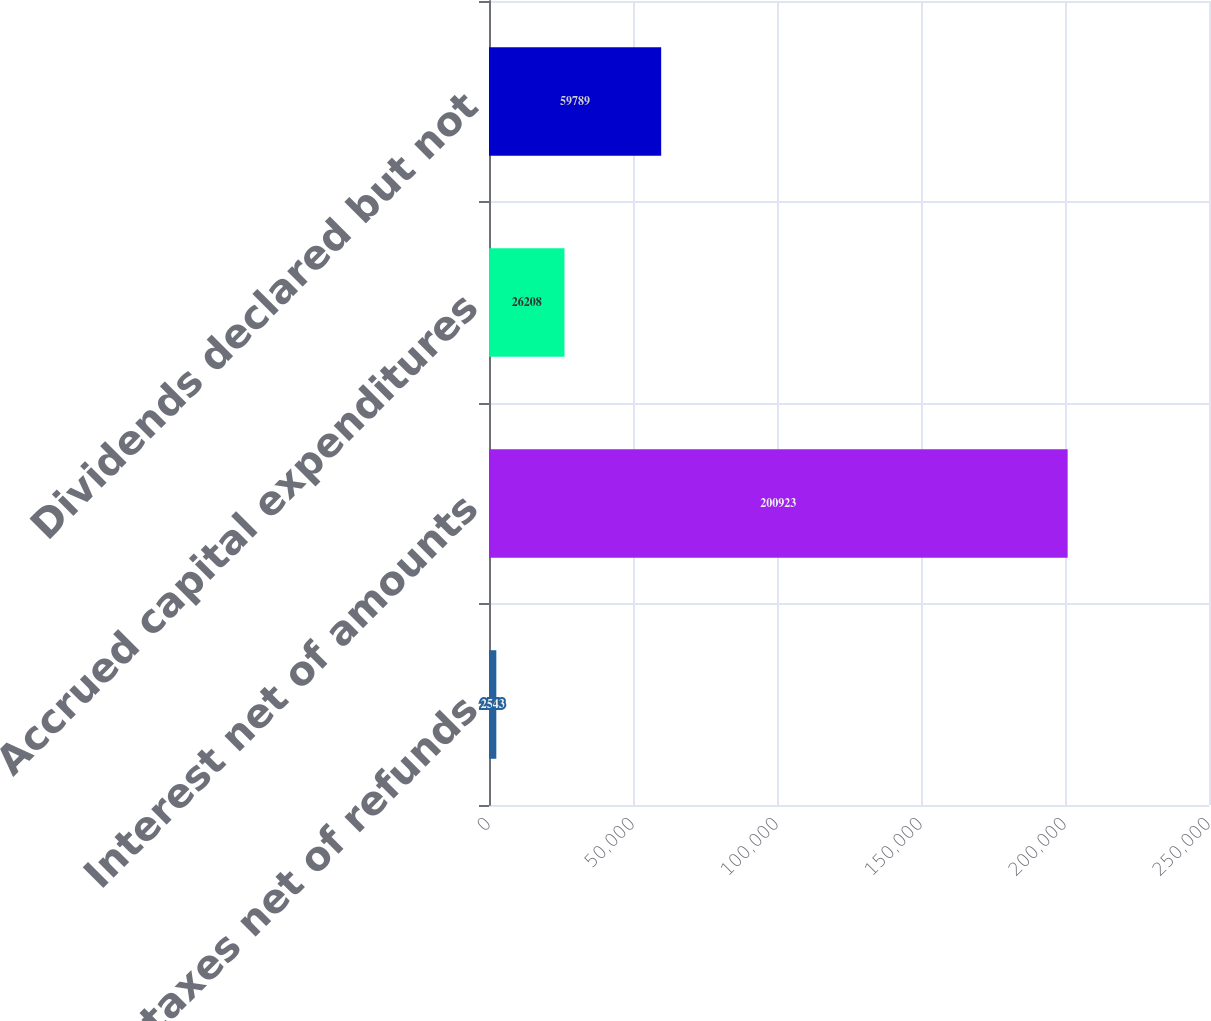Convert chart. <chart><loc_0><loc_0><loc_500><loc_500><bar_chart><fcel>Income taxes net of refunds<fcel>Interest net of amounts<fcel>Accrued capital expenditures<fcel>Dividends declared but not<nl><fcel>2543<fcel>200923<fcel>26208<fcel>59789<nl></chart> 